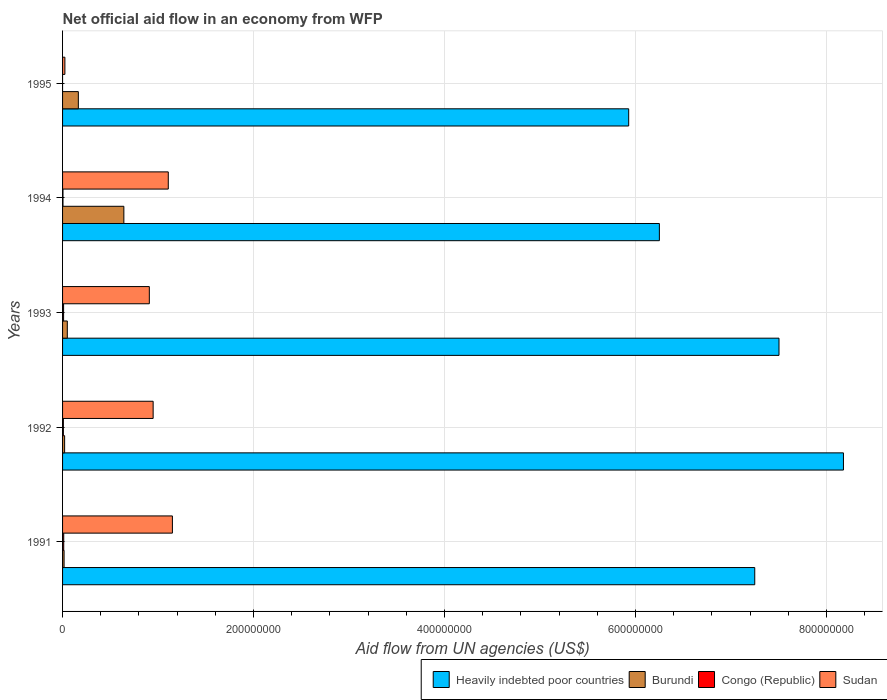How many different coloured bars are there?
Your answer should be very brief. 4. How many groups of bars are there?
Ensure brevity in your answer.  5. Are the number of bars per tick equal to the number of legend labels?
Your response must be concise. No. Are the number of bars on each tick of the Y-axis equal?
Offer a terse response. No. How many bars are there on the 3rd tick from the bottom?
Ensure brevity in your answer.  4. What is the net official aid flow in Burundi in 1993?
Offer a very short reply. 4.97e+06. Across all years, what is the maximum net official aid flow in Sudan?
Keep it short and to the point. 1.15e+08. Across all years, what is the minimum net official aid flow in Sudan?
Your response must be concise. 2.43e+06. What is the total net official aid flow in Heavily indebted poor countries in the graph?
Give a very brief answer. 3.51e+09. What is the difference between the net official aid flow in Burundi in 1992 and that in 1995?
Ensure brevity in your answer.  -1.44e+07. What is the difference between the net official aid flow in Congo (Republic) in 1992 and the net official aid flow in Burundi in 1991?
Make the answer very short. -7.40e+05. What is the average net official aid flow in Heavily indebted poor countries per year?
Your answer should be very brief. 7.02e+08. In the year 1993, what is the difference between the net official aid flow in Heavily indebted poor countries and net official aid flow in Congo (Republic)?
Your response must be concise. 7.49e+08. What is the ratio of the net official aid flow in Congo (Republic) in 1992 to that in 1994?
Your answer should be compact. 1.93. Is the net official aid flow in Congo (Republic) in 1991 less than that in 1994?
Make the answer very short. No. Is the difference between the net official aid flow in Heavily indebted poor countries in 1991 and 1993 greater than the difference between the net official aid flow in Congo (Republic) in 1991 and 1993?
Offer a terse response. No. What is the difference between the highest and the second highest net official aid flow in Congo (Republic)?
Give a very brief answer. 1.40e+05. What is the difference between the highest and the lowest net official aid flow in Sudan?
Provide a short and direct response. 1.13e+08. In how many years, is the net official aid flow in Burundi greater than the average net official aid flow in Burundi taken over all years?
Your answer should be very brief. 1. Is the sum of the net official aid flow in Sudan in 1993 and 1995 greater than the maximum net official aid flow in Congo (Republic) across all years?
Ensure brevity in your answer.  Yes. Is it the case that in every year, the sum of the net official aid flow in Congo (Republic) and net official aid flow in Heavily indebted poor countries is greater than the sum of net official aid flow in Burundi and net official aid flow in Sudan?
Ensure brevity in your answer.  Yes. Is it the case that in every year, the sum of the net official aid flow in Sudan and net official aid flow in Congo (Republic) is greater than the net official aid flow in Burundi?
Your answer should be compact. No. How many bars are there?
Provide a short and direct response. 19. Are all the bars in the graph horizontal?
Keep it short and to the point. Yes. Does the graph contain grids?
Provide a short and direct response. Yes. Where does the legend appear in the graph?
Make the answer very short. Bottom right. How are the legend labels stacked?
Keep it short and to the point. Horizontal. What is the title of the graph?
Make the answer very short. Net official aid flow in an economy from WFP. Does "Iraq" appear as one of the legend labels in the graph?
Your answer should be very brief. No. What is the label or title of the X-axis?
Your answer should be compact. Aid flow from UN agencies (US$). What is the Aid flow from UN agencies (US$) of Heavily indebted poor countries in 1991?
Provide a short and direct response. 7.25e+08. What is the Aid flow from UN agencies (US$) in Burundi in 1991?
Your answer should be compact. 1.59e+06. What is the Aid flow from UN agencies (US$) of Congo (Republic) in 1991?
Provide a succinct answer. 1.22e+06. What is the Aid flow from UN agencies (US$) of Sudan in 1991?
Your answer should be very brief. 1.15e+08. What is the Aid flow from UN agencies (US$) of Heavily indebted poor countries in 1992?
Your response must be concise. 8.18e+08. What is the Aid flow from UN agencies (US$) in Burundi in 1992?
Give a very brief answer. 2.15e+06. What is the Aid flow from UN agencies (US$) in Congo (Republic) in 1992?
Make the answer very short. 8.50e+05. What is the Aid flow from UN agencies (US$) in Sudan in 1992?
Give a very brief answer. 9.48e+07. What is the Aid flow from UN agencies (US$) of Heavily indebted poor countries in 1993?
Provide a succinct answer. 7.50e+08. What is the Aid flow from UN agencies (US$) in Burundi in 1993?
Ensure brevity in your answer.  4.97e+06. What is the Aid flow from UN agencies (US$) of Congo (Republic) in 1993?
Your response must be concise. 1.08e+06. What is the Aid flow from UN agencies (US$) of Sudan in 1993?
Give a very brief answer. 9.08e+07. What is the Aid flow from UN agencies (US$) in Heavily indebted poor countries in 1994?
Keep it short and to the point. 6.25e+08. What is the Aid flow from UN agencies (US$) in Burundi in 1994?
Offer a terse response. 6.42e+07. What is the Aid flow from UN agencies (US$) of Congo (Republic) in 1994?
Your response must be concise. 4.40e+05. What is the Aid flow from UN agencies (US$) in Sudan in 1994?
Your answer should be very brief. 1.11e+08. What is the Aid flow from UN agencies (US$) of Heavily indebted poor countries in 1995?
Your response must be concise. 5.93e+08. What is the Aid flow from UN agencies (US$) of Burundi in 1995?
Ensure brevity in your answer.  1.65e+07. What is the Aid flow from UN agencies (US$) of Congo (Republic) in 1995?
Provide a succinct answer. 0. What is the Aid flow from UN agencies (US$) of Sudan in 1995?
Your response must be concise. 2.43e+06. Across all years, what is the maximum Aid flow from UN agencies (US$) in Heavily indebted poor countries?
Provide a short and direct response. 8.18e+08. Across all years, what is the maximum Aid flow from UN agencies (US$) in Burundi?
Offer a terse response. 6.42e+07. Across all years, what is the maximum Aid flow from UN agencies (US$) of Congo (Republic)?
Your response must be concise. 1.22e+06. Across all years, what is the maximum Aid flow from UN agencies (US$) of Sudan?
Ensure brevity in your answer.  1.15e+08. Across all years, what is the minimum Aid flow from UN agencies (US$) of Heavily indebted poor countries?
Offer a terse response. 5.93e+08. Across all years, what is the minimum Aid flow from UN agencies (US$) in Burundi?
Your answer should be compact. 1.59e+06. Across all years, what is the minimum Aid flow from UN agencies (US$) in Sudan?
Your response must be concise. 2.43e+06. What is the total Aid flow from UN agencies (US$) of Heavily indebted poor countries in the graph?
Offer a terse response. 3.51e+09. What is the total Aid flow from UN agencies (US$) of Burundi in the graph?
Ensure brevity in your answer.  8.94e+07. What is the total Aid flow from UN agencies (US$) in Congo (Republic) in the graph?
Your answer should be very brief. 3.59e+06. What is the total Aid flow from UN agencies (US$) in Sudan in the graph?
Give a very brief answer. 4.14e+08. What is the difference between the Aid flow from UN agencies (US$) in Heavily indebted poor countries in 1991 and that in 1992?
Keep it short and to the point. -9.29e+07. What is the difference between the Aid flow from UN agencies (US$) in Burundi in 1991 and that in 1992?
Ensure brevity in your answer.  -5.60e+05. What is the difference between the Aid flow from UN agencies (US$) of Sudan in 1991 and that in 1992?
Your answer should be very brief. 2.02e+07. What is the difference between the Aid flow from UN agencies (US$) of Heavily indebted poor countries in 1991 and that in 1993?
Your answer should be compact. -2.54e+07. What is the difference between the Aid flow from UN agencies (US$) of Burundi in 1991 and that in 1993?
Make the answer very short. -3.38e+06. What is the difference between the Aid flow from UN agencies (US$) of Congo (Republic) in 1991 and that in 1993?
Give a very brief answer. 1.40e+05. What is the difference between the Aid flow from UN agencies (US$) of Sudan in 1991 and that in 1993?
Give a very brief answer. 2.42e+07. What is the difference between the Aid flow from UN agencies (US$) of Heavily indebted poor countries in 1991 and that in 1994?
Provide a short and direct response. 9.99e+07. What is the difference between the Aid flow from UN agencies (US$) of Burundi in 1991 and that in 1994?
Your answer should be very brief. -6.26e+07. What is the difference between the Aid flow from UN agencies (US$) in Congo (Republic) in 1991 and that in 1994?
Your answer should be compact. 7.80e+05. What is the difference between the Aid flow from UN agencies (US$) in Sudan in 1991 and that in 1994?
Your answer should be compact. 4.32e+06. What is the difference between the Aid flow from UN agencies (US$) of Heavily indebted poor countries in 1991 and that in 1995?
Offer a very short reply. 1.32e+08. What is the difference between the Aid flow from UN agencies (US$) of Burundi in 1991 and that in 1995?
Your answer should be compact. -1.49e+07. What is the difference between the Aid flow from UN agencies (US$) in Sudan in 1991 and that in 1995?
Offer a very short reply. 1.13e+08. What is the difference between the Aid flow from UN agencies (US$) in Heavily indebted poor countries in 1992 and that in 1993?
Your answer should be very brief. 6.75e+07. What is the difference between the Aid flow from UN agencies (US$) in Burundi in 1992 and that in 1993?
Offer a terse response. -2.82e+06. What is the difference between the Aid flow from UN agencies (US$) in Congo (Republic) in 1992 and that in 1993?
Offer a terse response. -2.30e+05. What is the difference between the Aid flow from UN agencies (US$) of Heavily indebted poor countries in 1992 and that in 1994?
Your response must be concise. 1.93e+08. What is the difference between the Aid flow from UN agencies (US$) in Burundi in 1992 and that in 1994?
Your answer should be very brief. -6.20e+07. What is the difference between the Aid flow from UN agencies (US$) of Sudan in 1992 and that in 1994?
Provide a short and direct response. -1.58e+07. What is the difference between the Aid flow from UN agencies (US$) of Heavily indebted poor countries in 1992 and that in 1995?
Offer a terse response. 2.25e+08. What is the difference between the Aid flow from UN agencies (US$) in Burundi in 1992 and that in 1995?
Your response must be concise. -1.44e+07. What is the difference between the Aid flow from UN agencies (US$) of Sudan in 1992 and that in 1995?
Your answer should be very brief. 9.24e+07. What is the difference between the Aid flow from UN agencies (US$) of Heavily indebted poor countries in 1993 and that in 1994?
Offer a very short reply. 1.25e+08. What is the difference between the Aid flow from UN agencies (US$) of Burundi in 1993 and that in 1994?
Your response must be concise. -5.92e+07. What is the difference between the Aid flow from UN agencies (US$) in Congo (Republic) in 1993 and that in 1994?
Provide a short and direct response. 6.40e+05. What is the difference between the Aid flow from UN agencies (US$) in Sudan in 1993 and that in 1994?
Ensure brevity in your answer.  -1.98e+07. What is the difference between the Aid flow from UN agencies (US$) of Heavily indebted poor countries in 1993 and that in 1995?
Your answer should be very brief. 1.57e+08. What is the difference between the Aid flow from UN agencies (US$) of Burundi in 1993 and that in 1995?
Provide a succinct answer. -1.16e+07. What is the difference between the Aid flow from UN agencies (US$) in Sudan in 1993 and that in 1995?
Offer a very short reply. 8.84e+07. What is the difference between the Aid flow from UN agencies (US$) of Heavily indebted poor countries in 1994 and that in 1995?
Provide a short and direct response. 3.21e+07. What is the difference between the Aid flow from UN agencies (US$) of Burundi in 1994 and that in 1995?
Your answer should be compact. 4.77e+07. What is the difference between the Aid flow from UN agencies (US$) of Sudan in 1994 and that in 1995?
Keep it short and to the point. 1.08e+08. What is the difference between the Aid flow from UN agencies (US$) of Heavily indebted poor countries in 1991 and the Aid flow from UN agencies (US$) of Burundi in 1992?
Your answer should be compact. 7.23e+08. What is the difference between the Aid flow from UN agencies (US$) of Heavily indebted poor countries in 1991 and the Aid flow from UN agencies (US$) of Congo (Republic) in 1992?
Ensure brevity in your answer.  7.24e+08. What is the difference between the Aid flow from UN agencies (US$) in Heavily indebted poor countries in 1991 and the Aid flow from UN agencies (US$) in Sudan in 1992?
Offer a terse response. 6.30e+08. What is the difference between the Aid flow from UN agencies (US$) of Burundi in 1991 and the Aid flow from UN agencies (US$) of Congo (Republic) in 1992?
Keep it short and to the point. 7.40e+05. What is the difference between the Aid flow from UN agencies (US$) of Burundi in 1991 and the Aid flow from UN agencies (US$) of Sudan in 1992?
Your response must be concise. -9.33e+07. What is the difference between the Aid flow from UN agencies (US$) in Congo (Republic) in 1991 and the Aid flow from UN agencies (US$) in Sudan in 1992?
Provide a short and direct response. -9.36e+07. What is the difference between the Aid flow from UN agencies (US$) in Heavily indebted poor countries in 1991 and the Aid flow from UN agencies (US$) in Burundi in 1993?
Keep it short and to the point. 7.20e+08. What is the difference between the Aid flow from UN agencies (US$) of Heavily indebted poor countries in 1991 and the Aid flow from UN agencies (US$) of Congo (Republic) in 1993?
Offer a terse response. 7.24e+08. What is the difference between the Aid flow from UN agencies (US$) of Heavily indebted poor countries in 1991 and the Aid flow from UN agencies (US$) of Sudan in 1993?
Give a very brief answer. 6.34e+08. What is the difference between the Aid flow from UN agencies (US$) of Burundi in 1991 and the Aid flow from UN agencies (US$) of Congo (Republic) in 1993?
Provide a short and direct response. 5.10e+05. What is the difference between the Aid flow from UN agencies (US$) in Burundi in 1991 and the Aid flow from UN agencies (US$) in Sudan in 1993?
Provide a short and direct response. -8.93e+07. What is the difference between the Aid flow from UN agencies (US$) of Congo (Republic) in 1991 and the Aid flow from UN agencies (US$) of Sudan in 1993?
Your answer should be compact. -8.96e+07. What is the difference between the Aid flow from UN agencies (US$) of Heavily indebted poor countries in 1991 and the Aid flow from UN agencies (US$) of Burundi in 1994?
Keep it short and to the point. 6.61e+08. What is the difference between the Aid flow from UN agencies (US$) of Heavily indebted poor countries in 1991 and the Aid flow from UN agencies (US$) of Congo (Republic) in 1994?
Give a very brief answer. 7.24e+08. What is the difference between the Aid flow from UN agencies (US$) of Heavily indebted poor countries in 1991 and the Aid flow from UN agencies (US$) of Sudan in 1994?
Keep it short and to the point. 6.14e+08. What is the difference between the Aid flow from UN agencies (US$) in Burundi in 1991 and the Aid flow from UN agencies (US$) in Congo (Republic) in 1994?
Your response must be concise. 1.15e+06. What is the difference between the Aid flow from UN agencies (US$) in Burundi in 1991 and the Aid flow from UN agencies (US$) in Sudan in 1994?
Your response must be concise. -1.09e+08. What is the difference between the Aid flow from UN agencies (US$) of Congo (Republic) in 1991 and the Aid flow from UN agencies (US$) of Sudan in 1994?
Your answer should be very brief. -1.09e+08. What is the difference between the Aid flow from UN agencies (US$) of Heavily indebted poor countries in 1991 and the Aid flow from UN agencies (US$) of Burundi in 1995?
Your response must be concise. 7.08e+08. What is the difference between the Aid flow from UN agencies (US$) of Heavily indebted poor countries in 1991 and the Aid flow from UN agencies (US$) of Sudan in 1995?
Keep it short and to the point. 7.22e+08. What is the difference between the Aid flow from UN agencies (US$) of Burundi in 1991 and the Aid flow from UN agencies (US$) of Sudan in 1995?
Your answer should be compact. -8.40e+05. What is the difference between the Aid flow from UN agencies (US$) in Congo (Republic) in 1991 and the Aid flow from UN agencies (US$) in Sudan in 1995?
Keep it short and to the point. -1.21e+06. What is the difference between the Aid flow from UN agencies (US$) of Heavily indebted poor countries in 1992 and the Aid flow from UN agencies (US$) of Burundi in 1993?
Offer a terse response. 8.13e+08. What is the difference between the Aid flow from UN agencies (US$) of Heavily indebted poor countries in 1992 and the Aid flow from UN agencies (US$) of Congo (Republic) in 1993?
Make the answer very short. 8.17e+08. What is the difference between the Aid flow from UN agencies (US$) of Heavily indebted poor countries in 1992 and the Aid flow from UN agencies (US$) of Sudan in 1993?
Offer a terse response. 7.27e+08. What is the difference between the Aid flow from UN agencies (US$) in Burundi in 1992 and the Aid flow from UN agencies (US$) in Congo (Republic) in 1993?
Provide a short and direct response. 1.07e+06. What is the difference between the Aid flow from UN agencies (US$) of Burundi in 1992 and the Aid flow from UN agencies (US$) of Sudan in 1993?
Offer a very short reply. -8.87e+07. What is the difference between the Aid flow from UN agencies (US$) in Congo (Republic) in 1992 and the Aid flow from UN agencies (US$) in Sudan in 1993?
Offer a very short reply. -9.00e+07. What is the difference between the Aid flow from UN agencies (US$) of Heavily indebted poor countries in 1992 and the Aid flow from UN agencies (US$) of Burundi in 1994?
Your answer should be very brief. 7.54e+08. What is the difference between the Aid flow from UN agencies (US$) in Heavily indebted poor countries in 1992 and the Aid flow from UN agencies (US$) in Congo (Republic) in 1994?
Your response must be concise. 8.17e+08. What is the difference between the Aid flow from UN agencies (US$) of Heavily indebted poor countries in 1992 and the Aid flow from UN agencies (US$) of Sudan in 1994?
Keep it short and to the point. 7.07e+08. What is the difference between the Aid flow from UN agencies (US$) of Burundi in 1992 and the Aid flow from UN agencies (US$) of Congo (Republic) in 1994?
Give a very brief answer. 1.71e+06. What is the difference between the Aid flow from UN agencies (US$) in Burundi in 1992 and the Aid flow from UN agencies (US$) in Sudan in 1994?
Your answer should be very brief. -1.09e+08. What is the difference between the Aid flow from UN agencies (US$) in Congo (Republic) in 1992 and the Aid flow from UN agencies (US$) in Sudan in 1994?
Ensure brevity in your answer.  -1.10e+08. What is the difference between the Aid flow from UN agencies (US$) in Heavily indebted poor countries in 1992 and the Aid flow from UN agencies (US$) in Burundi in 1995?
Your answer should be very brief. 8.01e+08. What is the difference between the Aid flow from UN agencies (US$) in Heavily indebted poor countries in 1992 and the Aid flow from UN agencies (US$) in Sudan in 1995?
Your answer should be very brief. 8.15e+08. What is the difference between the Aid flow from UN agencies (US$) of Burundi in 1992 and the Aid flow from UN agencies (US$) of Sudan in 1995?
Provide a short and direct response. -2.80e+05. What is the difference between the Aid flow from UN agencies (US$) of Congo (Republic) in 1992 and the Aid flow from UN agencies (US$) of Sudan in 1995?
Ensure brevity in your answer.  -1.58e+06. What is the difference between the Aid flow from UN agencies (US$) in Heavily indebted poor countries in 1993 and the Aid flow from UN agencies (US$) in Burundi in 1994?
Ensure brevity in your answer.  6.86e+08. What is the difference between the Aid flow from UN agencies (US$) of Heavily indebted poor countries in 1993 and the Aid flow from UN agencies (US$) of Congo (Republic) in 1994?
Keep it short and to the point. 7.50e+08. What is the difference between the Aid flow from UN agencies (US$) of Heavily indebted poor countries in 1993 and the Aid flow from UN agencies (US$) of Sudan in 1994?
Give a very brief answer. 6.40e+08. What is the difference between the Aid flow from UN agencies (US$) of Burundi in 1993 and the Aid flow from UN agencies (US$) of Congo (Republic) in 1994?
Your answer should be very brief. 4.53e+06. What is the difference between the Aid flow from UN agencies (US$) of Burundi in 1993 and the Aid flow from UN agencies (US$) of Sudan in 1994?
Your answer should be compact. -1.06e+08. What is the difference between the Aid flow from UN agencies (US$) of Congo (Republic) in 1993 and the Aid flow from UN agencies (US$) of Sudan in 1994?
Provide a succinct answer. -1.10e+08. What is the difference between the Aid flow from UN agencies (US$) in Heavily indebted poor countries in 1993 and the Aid flow from UN agencies (US$) in Burundi in 1995?
Keep it short and to the point. 7.34e+08. What is the difference between the Aid flow from UN agencies (US$) in Heavily indebted poor countries in 1993 and the Aid flow from UN agencies (US$) in Sudan in 1995?
Your response must be concise. 7.48e+08. What is the difference between the Aid flow from UN agencies (US$) in Burundi in 1993 and the Aid flow from UN agencies (US$) in Sudan in 1995?
Your answer should be compact. 2.54e+06. What is the difference between the Aid flow from UN agencies (US$) of Congo (Republic) in 1993 and the Aid flow from UN agencies (US$) of Sudan in 1995?
Your answer should be compact. -1.35e+06. What is the difference between the Aid flow from UN agencies (US$) of Heavily indebted poor countries in 1994 and the Aid flow from UN agencies (US$) of Burundi in 1995?
Offer a very short reply. 6.08e+08. What is the difference between the Aid flow from UN agencies (US$) in Heavily indebted poor countries in 1994 and the Aid flow from UN agencies (US$) in Sudan in 1995?
Offer a very short reply. 6.23e+08. What is the difference between the Aid flow from UN agencies (US$) of Burundi in 1994 and the Aid flow from UN agencies (US$) of Sudan in 1995?
Provide a succinct answer. 6.18e+07. What is the difference between the Aid flow from UN agencies (US$) in Congo (Republic) in 1994 and the Aid flow from UN agencies (US$) in Sudan in 1995?
Give a very brief answer. -1.99e+06. What is the average Aid flow from UN agencies (US$) of Heavily indebted poor countries per year?
Make the answer very short. 7.02e+08. What is the average Aid flow from UN agencies (US$) of Burundi per year?
Offer a terse response. 1.79e+07. What is the average Aid flow from UN agencies (US$) of Congo (Republic) per year?
Provide a short and direct response. 7.18e+05. What is the average Aid flow from UN agencies (US$) of Sudan per year?
Your answer should be compact. 8.28e+07. In the year 1991, what is the difference between the Aid flow from UN agencies (US$) of Heavily indebted poor countries and Aid flow from UN agencies (US$) of Burundi?
Keep it short and to the point. 7.23e+08. In the year 1991, what is the difference between the Aid flow from UN agencies (US$) in Heavily indebted poor countries and Aid flow from UN agencies (US$) in Congo (Republic)?
Offer a very short reply. 7.24e+08. In the year 1991, what is the difference between the Aid flow from UN agencies (US$) of Heavily indebted poor countries and Aid flow from UN agencies (US$) of Sudan?
Provide a short and direct response. 6.10e+08. In the year 1991, what is the difference between the Aid flow from UN agencies (US$) of Burundi and Aid flow from UN agencies (US$) of Sudan?
Keep it short and to the point. -1.13e+08. In the year 1991, what is the difference between the Aid flow from UN agencies (US$) in Congo (Republic) and Aid flow from UN agencies (US$) in Sudan?
Your answer should be very brief. -1.14e+08. In the year 1992, what is the difference between the Aid flow from UN agencies (US$) of Heavily indebted poor countries and Aid flow from UN agencies (US$) of Burundi?
Give a very brief answer. 8.16e+08. In the year 1992, what is the difference between the Aid flow from UN agencies (US$) of Heavily indebted poor countries and Aid flow from UN agencies (US$) of Congo (Republic)?
Ensure brevity in your answer.  8.17e+08. In the year 1992, what is the difference between the Aid flow from UN agencies (US$) of Heavily indebted poor countries and Aid flow from UN agencies (US$) of Sudan?
Provide a succinct answer. 7.23e+08. In the year 1992, what is the difference between the Aid flow from UN agencies (US$) of Burundi and Aid flow from UN agencies (US$) of Congo (Republic)?
Provide a succinct answer. 1.30e+06. In the year 1992, what is the difference between the Aid flow from UN agencies (US$) of Burundi and Aid flow from UN agencies (US$) of Sudan?
Your answer should be very brief. -9.27e+07. In the year 1992, what is the difference between the Aid flow from UN agencies (US$) in Congo (Republic) and Aid flow from UN agencies (US$) in Sudan?
Provide a short and direct response. -9.40e+07. In the year 1993, what is the difference between the Aid flow from UN agencies (US$) of Heavily indebted poor countries and Aid flow from UN agencies (US$) of Burundi?
Your response must be concise. 7.45e+08. In the year 1993, what is the difference between the Aid flow from UN agencies (US$) of Heavily indebted poor countries and Aid flow from UN agencies (US$) of Congo (Republic)?
Your answer should be compact. 7.49e+08. In the year 1993, what is the difference between the Aid flow from UN agencies (US$) of Heavily indebted poor countries and Aid flow from UN agencies (US$) of Sudan?
Your response must be concise. 6.59e+08. In the year 1993, what is the difference between the Aid flow from UN agencies (US$) of Burundi and Aid flow from UN agencies (US$) of Congo (Republic)?
Keep it short and to the point. 3.89e+06. In the year 1993, what is the difference between the Aid flow from UN agencies (US$) of Burundi and Aid flow from UN agencies (US$) of Sudan?
Offer a terse response. -8.59e+07. In the year 1993, what is the difference between the Aid flow from UN agencies (US$) of Congo (Republic) and Aid flow from UN agencies (US$) of Sudan?
Ensure brevity in your answer.  -8.98e+07. In the year 1994, what is the difference between the Aid flow from UN agencies (US$) of Heavily indebted poor countries and Aid flow from UN agencies (US$) of Burundi?
Your response must be concise. 5.61e+08. In the year 1994, what is the difference between the Aid flow from UN agencies (US$) of Heavily indebted poor countries and Aid flow from UN agencies (US$) of Congo (Republic)?
Offer a terse response. 6.25e+08. In the year 1994, what is the difference between the Aid flow from UN agencies (US$) of Heavily indebted poor countries and Aid flow from UN agencies (US$) of Sudan?
Give a very brief answer. 5.14e+08. In the year 1994, what is the difference between the Aid flow from UN agencies (US$) in Burundi and Aid flow from UN agencies (US$) in Congo (Republic)?
Offer a terse response. 6.38e+07. In the year 1994, what is the difference between the Aid flow from UN agencies (US$) in Burundi and Aid flow from UN agencies (US$) in Sudan?
Your response must be concise. -4.65e+07. In the year 1994, what is the difference between the Aid flow from UN agencies (US$) in Congo (Republic) and Aid flow from UN agencies (US$) in Sudan?
Make the answer very short. -1.10e+08. In the year 1995, what is the difference between the Aid flow from UN agencies (US$) of Heavily indebted poor countries and Aid flow from UN agencies (US$) of Burundi?
Give a very brief answer. 5.76e+08. In the year 1995, what is the difference between the Aid flow from UN agencies (US$) of Heavily indebted poor countries and Aid flow from UN agencies (US$) of Sudan?
Keep it short and to the point. 5.90e+08. In the year 1995, what is the difference between the Aid flow from UN agencies (US$) in Burundi and Aid flow from UN agencies (US$) in Sudan?
Your response must be concise. 1.41e+07. What is the ratio of the Aid flow from UN agencies (US$) in Heavily indebted poor countries in 1991 to that in 1992?
Your answer should be very brief. 0.89. What is the ratio of the Aid flow from UN agencies (US$) of Burundi in 1991 to that in 1992?
Ensure brevity in your answer.  0.74. What is the ratio of the Aid flow from UN agencies (US$) of Congo (Republic) in 1991 to that in 1992?
Offer a very short reply. 1.44. What is the ratio of the Aid flow from UN agencies (US$) of Sudan in 1991 to that in 1992?
Your response must be concise. 1.21. What is the ratio of the Aid flow from UN agencies (US$) of Heavily indebted poor countries in 1991 to that in 1993?
Your response must be concise. 0.97. What is the ratio of the Aid flow from UN agencies (US$) of Burundi in 1991 to that in 1993?
Make the answer very short. 0.32. What is the ratio of the Aid flow from UN agencies (US$) of Congo (Republic) in 1991 to that in 1993?
Provide a succinct answer. 1.13. What is the ratio of the Aid flow from UN agencies (US$) of Sudan in 1991 to that in 1993?
Ensure brevity in your answer.  1.27. What is the ratio of the Aid flow from UN agencies (US$) in Heavily indebted poor countries in 1991 to that in 1994?
Offer a very short reply. 1.16. What is the ratio of the Aid flow from UN agencies (US$) in Burundi in 1991 to that in 1994?
Keep it short and to the point. 0.02. What is the ratio of the Aid flow from UN agencies (US$) in Congo (Republic) in 1991 to that in 1994?
Your response must be concise. 2.77. What is the ratio of the Aid flow from UN agencies (US$) of Sudan in 1991 to that in 1994?
Make the answer very short. 1.04. What is the ratio of the Aid flow from UN agencies (US$) of Heavily indebted poor countries in 1991 to that in 1995?
Make the answer very short. 1.22. What is the ratio of the Aid flow from UN agencies (US$) of Burundi in 1991 to that in 1995?
Keep it short and to the point. 0.1. What is the ratio of the Aid flow from UN agencies (US$) of Sudan in 1991 to that in 1995?
Ensure brevity in your answer.  47.33. What is the ratio of the Aid flow from UN agencies (US$) in Heavily indebted poor countries in 1992 to that in 1993?
Keep it short and to the point. 1.09. What is the ratio of the Aid flow from UN agencies (US$) of Burundi in 1992 to that in 1993?
Your answer should be very brief. 0.43. What is the ratio of the Aid flow from UN agencies (US$) in Congo (Republic) in 1992 to that in 1993?
Provide a succinct answer. 0.79. What is the ratio of the Aid flow from UN agencies (US$) in Sudan in 1992 to that in 1993?
Give a very brief answer. 1.04. What is the ratio of the Aid flow from UN agencies (US$) of Heavily indebted poor countries in 1992 to that in 1994?
Your answer should be compact. 1.31. What is the ratio of the Aid flow from UN agencies (US$) in Burundi in 1992 to that in 1994?
Offer a terse response. 0.03. What is the ratio of the Aid flow from UN agencies (US$) of Congo (Republic) in 1992 to that in 1994?
Your response must be concise. 1.93. What is the ratio of the Aid flow from UN agencies (US$) of Sudan in 1992 to that in 1994?
Keep it short and to the point. 0.86. What is the ratio of the Aid flow from UN agencies (US$) in Heavily indebted poor countries in 1992 to that in 1995?
Your answer should be very brief. 1.38. What is the ratio of the Aid flow from UN agencies (US$) in Burundi in 1992 to that in 1995?
Make the answer very short. 0.13. What is the ratio of the Aid flow from UN agencies (US$) of Sudan in 1992 to that in 1995?
Keep it short and to the point. 39.03. What is the ratio of the Aid flow from UN agencies (US$) in Heavily indebted poor countries in 1993 to that in 1994?
Your answer should be very brief. 1.2. What is the ratio of the Aid flow from UN agencies (US$) of Burundi in 1993 to that in 1994?
Make the answer very short. 0.08. What is the ratio of the Aid flow from UN agencies (US$) in Congo (Republic) in 1993 to that in 1994?
Give a very brief answer. 2.45. What is the ratio of the Aid flow from UN agencies (US$) of Sudan in 1993 to that in 1994?
Your answer should be very brief. 0.82. What is the ratio of the Aid flow from UN agencies (US$) in Heavily indebted poor countries in 1993 to that in 1995?
Keep it short and to the point. 1.27. What is the ratio of the Aid flow from UN agencies (US$) of Burundi in 1993 to that in 1995?
Your answer should be very brief. 0.3. What is the ratio of the Aid flow from UN agencies (US$) of Sudan in 1993 to that in 1995?
Make the answer very short. 37.39. What is the ratio of the Aid flow from UN agencies (US$) of Heavily indebted poor countries in 1994 to that in 1995?
Offer a very short reply. 1.05. What is the ratio of the Aid flow from UN agencies (US$) in Burundi in 1994 to that in 1995?
Keep it short and to the point. 3.88. What is the ratio of the Aid flow from UN agencies (US$) of Sudan in 1994 to that in 1995?
Provide a short and direct response. 45.56. What is the difference between the highest and the second highest Aid flow from UN agencies (US$) in Heavily indebted poor countries?
Your response must be concise. 6.75e+07. What is the difference between the highest and the second highest Aid flow from UN agencies (US$) in Burundi?
Give a very brief answer. 4.77e+07. What is the difference between the highest and the second highest Aid flow from UN agencies (US$) of Sudan?
Offer a very short reply. 4.32e+06. What is the difference between the highest and the lowest Aid flow from UN agencies (US$) in Heavily indebted poor countries?
Ensure brevity in your answer.  2.25e+08. What is the difference between the highest and the lowest Aid flow from UN agencies (US$) of Burundi?
Give a very brief answer. 6.26e+07. What is the difference between the highest and the lowest Aid flow from UN agencies (US$) in Congo (Republic)?
Ensure brevity in your answer.  1.22e+06. What is the difference between the highest and the lowest Aid flow from UN agencies (US$) in Sudan?
Keep it short and to the point. 1.13e+08. 